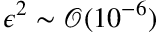Convert formula to latex. <formula><loc_0><loc_0><loc_500><loc_500>\epsilon ^ { 2 } \sim \mathcal { O } ( 1 0 ^ { - 6 } )</formula> 